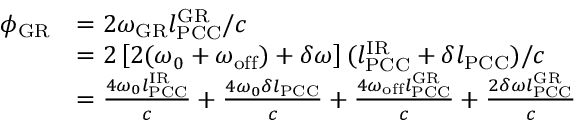Convert formula to latex. <formula><loc_0><loc_0><loc_500><loc_500>\begin{array} { r l } { \phi _ { G R } } & { = 2 \omega _ { G R } l _ { P C C } ^ { G R } / c } \\ & { = 2 \left [ 2 ( \omega _ { 0 } + \omega _ { o f f } ) + \delta \omega \right ] ( l _ { P C C } ^ { I R } + \delta l _ { P C C } ) / c } \\ & { = \frac { 4 \omega _ { 0 } l _ { P C C } ^ { I R } } { c } + \frac { 4 \omega _ { 0 } \delta l _ { P C C } } { c } + \frac { 4 \omega _ { o f f } l _ { P C C } ^ { G R } } { c } + \frac { 2 \delta \omega l _ { P C C } ^ { G R } } { c } } \end{array}</formula> 